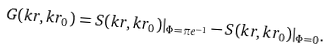Convert formula to latex. <formula><loc_0><loc_0><loc_500><loc_500>G ( k r , k r _ { 0 } ) = S ( k r , k r _ { 0 } ) | _ { \Phi = \pi e ^ { - 1 } } - S ( k r , k r _ { 0 } ) | _ { \Phi = 0 } .</formula> 